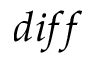Convert formula to latex. <formula><loc_0><loc_0><loc_500><loc_500>d i f f</formula> 